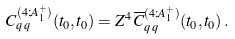<formula> <loc_0><loc_0><loc_500><loc_500>C ^ { ( 4 ; A ^ { + } _ { 1 } ) } _ { q \, q } ( t _ { 0 } , t _ { 0 } ) = Z ^ { 4 } \, \overline { C } ^ { ( 4 ; A ^ { + } _ { 1 } ) } _ { q \, q } ( t _ { 0 } , t _ { 0 } ) \, .</formula> 